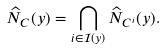<formula> <loc_0><loc_0><loc_500><loc_500>\widehat { N } _ { C } ( y ) = \bigcap _ { i \in \mathcal { I } ( y ) } \widehat { N } _ { C ^ { i } } ( y ) .</formula> 